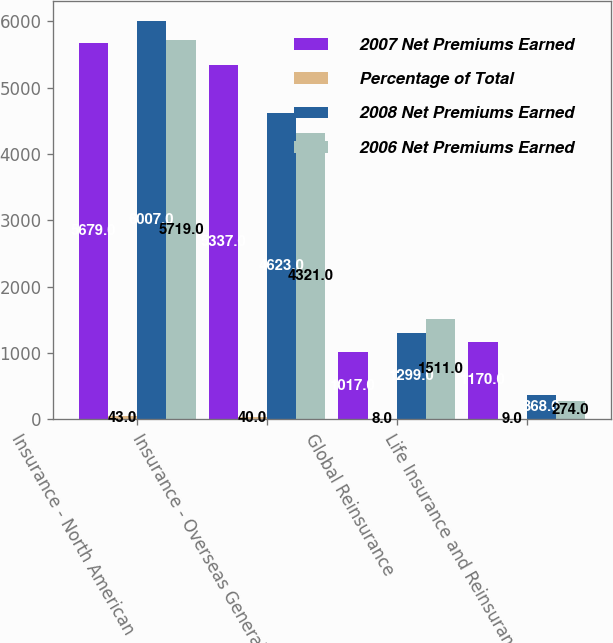<chart> <loc_0><loc_0><loc_500><loc_500><stacked_bar_chart><ecel><fcel>Insurance - North American<fcel>Insurance - Overseas General<fcel>Global Reinsurance<fcel>Life Insurance and Reinsurance<nl><fcel>2007 Net Premiums Earned<fcel>5679<fcel>5337<fcel>1017<fcel>1170<nl><fcel>Percentage of Total<fcel>43<fcel>40<fcel>8<fcel>9<nl><fcel>2008 Net Premiums Earned<fcel>6007<fcel>4623<fcel>1299<fcel>368<nl><fcel>2006 Net Premiums Earned<fcel>5719<fcel>4321<fcel>1511<fcel>274<nl></chart> 